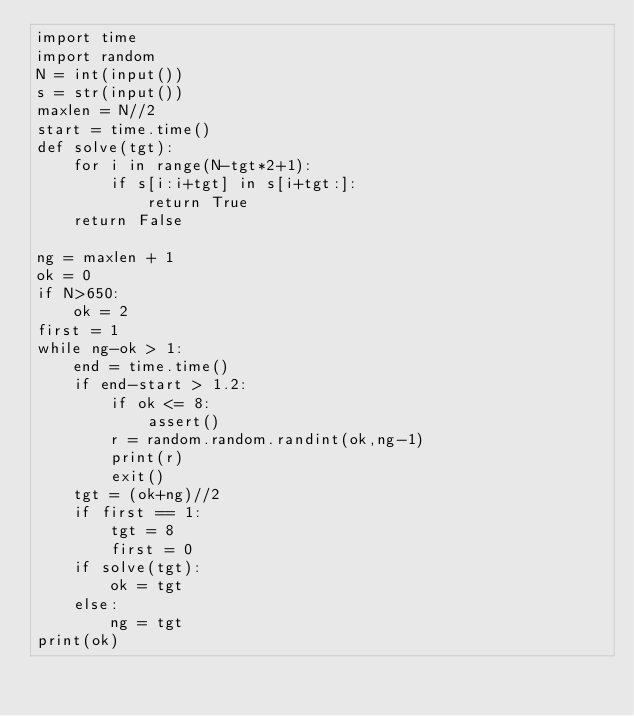<code> <loc_0><loc_0><loc_500><loc_500><_Python_>import time
import random
N = int(input())
s = str(input())
maxlen = N//2
start = time.time()
def solve(tgt):
    for i in range(N-tgt*2+1):
        if s[i:i+tgt] in s[i+tgt:]:
            return True
    return False

ng = maxlen + 1
ok = 0
if N>650:
    ok = 2
first = 1
while ng-ok > 1:
    end = time.time()
    if end-start > 1.2:
        if ok <= 8:
            assert()
        r = random.random.randint(ok,ng-1)
        print(r)
        exit()
    tgt = (ok+ng)//2
    if first == 1:
        tgt = 8
        first = 0
    if solve(tgt):
        ok = tgt
    else:
        ng = tgt
print(ok)
</code> 